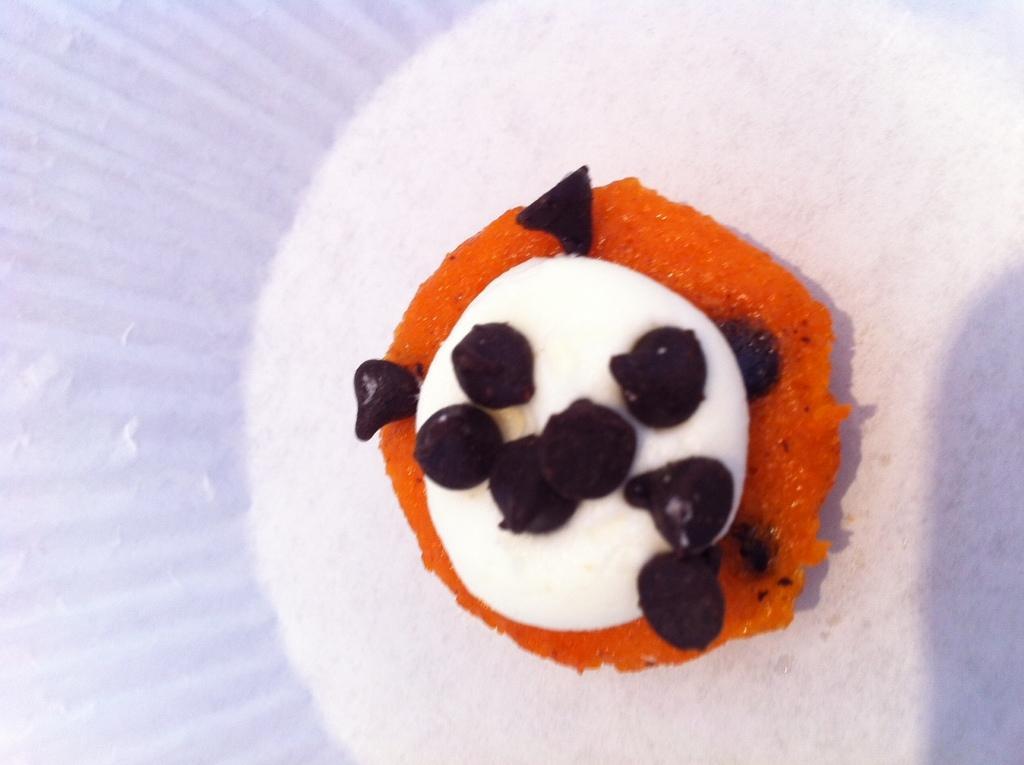Please provide a concise description of this image. In this image, we can see a food item. 